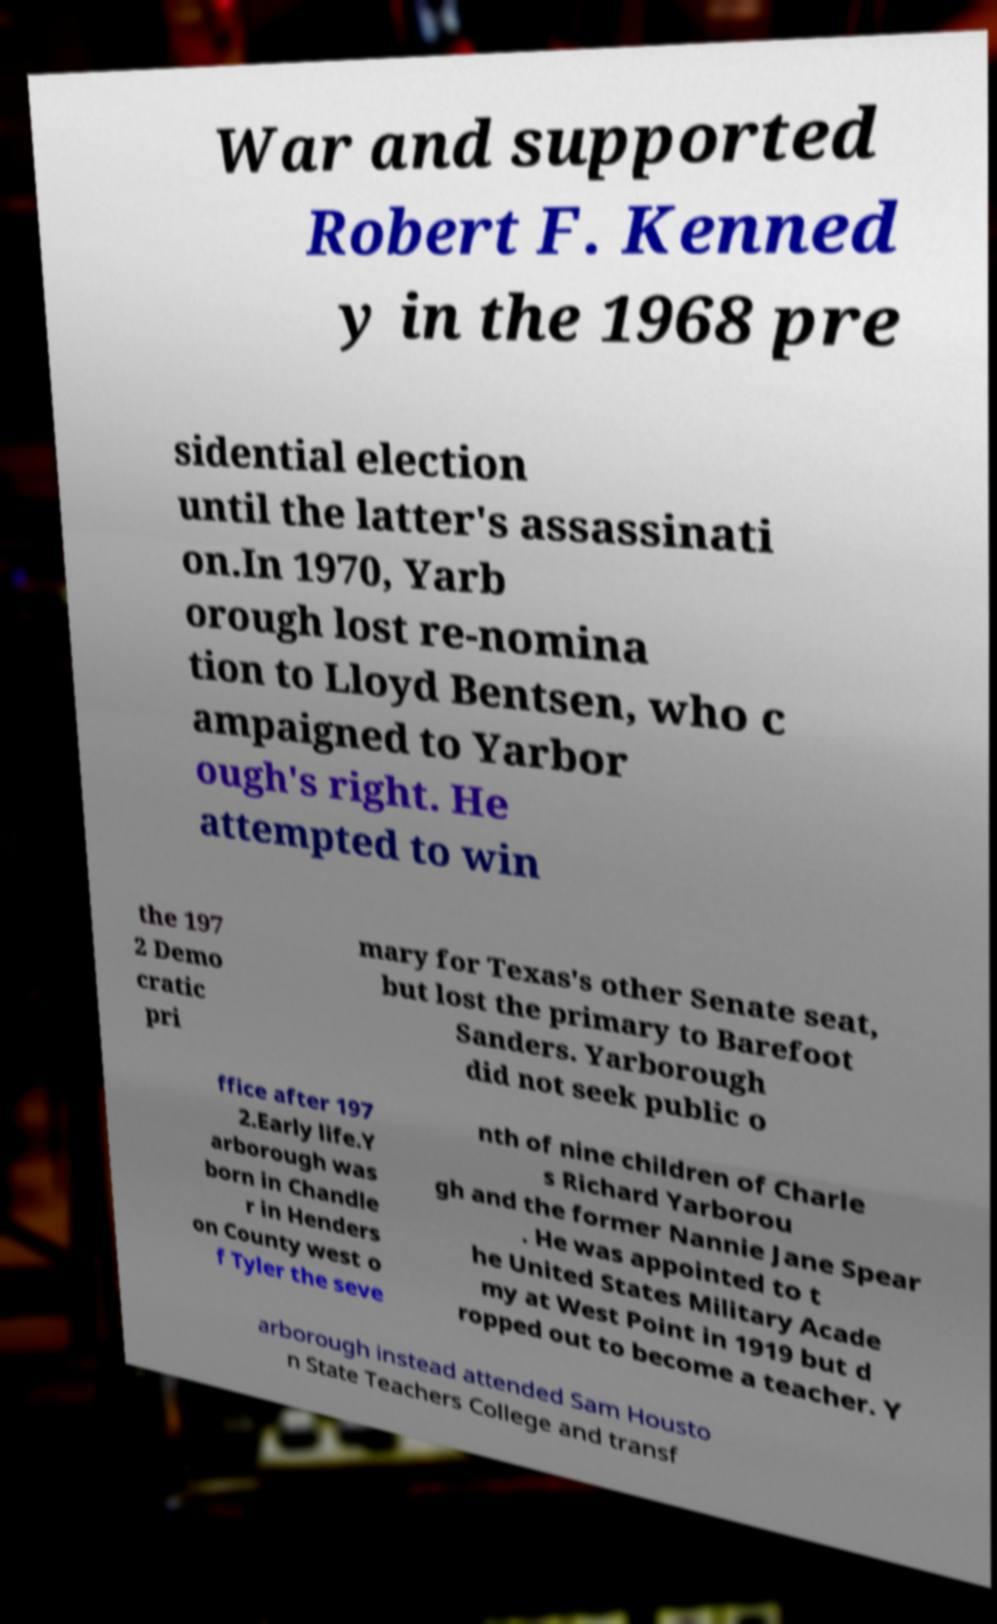Please read and relay the text visible in this image. What does it say? War and supported Robert F. Kenned y in the 1968 pre sidential election until the latter's assassinati on.In 1970, Yarb orough lost re-nomina tion to Lloyd Bentsen, who c ampaigned to Yarbor ough's right. He attempted to win the 197 2 Demo cratic pri mary for Texas's other Senate seat, but lost the primary to Barefoot Sanders. Yarborough did not seek public o ffice after 197 2.Early life.Y arborough was born in Chandle r in Henders on County west o f Tyler the seve nth of nine children of Charle s Richard Yarborou gh and the former Nannie Jane Spear . He was appointed to t he United States Military Acade my at West Point in 1919 but d ropped out to become a teacher. Y arborough instead attended Sam Housto n State Teachers College and transf 